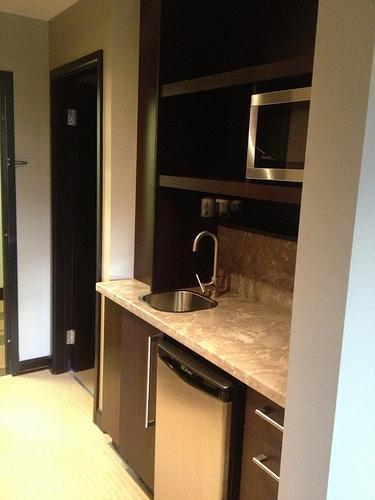How many faucets are pictured?
Give a very brief answer. 1. How many doors are visible?
Give a very brief answer. 1. 